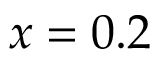<formula> <loc_0><loc_0><loc_500><loc_500>x = 0 . 2</formula> 